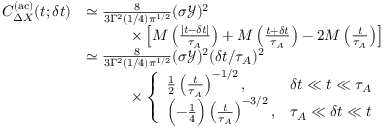<formula> <loc_0><loc_0><loc_500><loc_500>\begin{array} { r l } { C _ { \Delta X } ^ { ( a c ) } ( t ; \delta t ) } & { \simeq \frac { 8 } { 3 \Gamma ^ { 2 } ( 1 / 4 ) { \pi } ^ { 1 / 2 } } ( \sigma \mathcal { Y } ) ^ { 2 } } \\ & { \quad \times \left [ M \left ( \frac { | t - \delta t | } { \tau _ { A } } \right ) + M \left ( \frac { t + \delta t } { \tau _ { A } } \right ) - 2 M \left ( \frac { t } { \tau _ { A } } \right ) \right ] } \\ & { \simeq \frac { 8 } { 3 \Gamma ^ { 2 } ( 1 / 4 ) { \pi } ^ { 1 / 2 } } ( \sigma \mathcal { Y } ) ^ { 2 } ( \delta t / \tau _ { A } ) ^ { 2 } } \\ & { \quad \times \left \{ \begin{array} { l r } { \frac { 1 } { 2 } \left ( \frac { t } { \tau _ { A } } \right ) ^ { - 1 / 2 } , } & { \delta t \ll t \ll \tau _ { A } } \\ { \left ( - \frac { 1 } { 4 } \right ) \left ( \frac { t } { \tau _ { A } } \right ) ^ { - 3 / 2 } , } & { \tau _ { A } \ll \delta t \ll t } \end{array} } \end{array}</formula> 